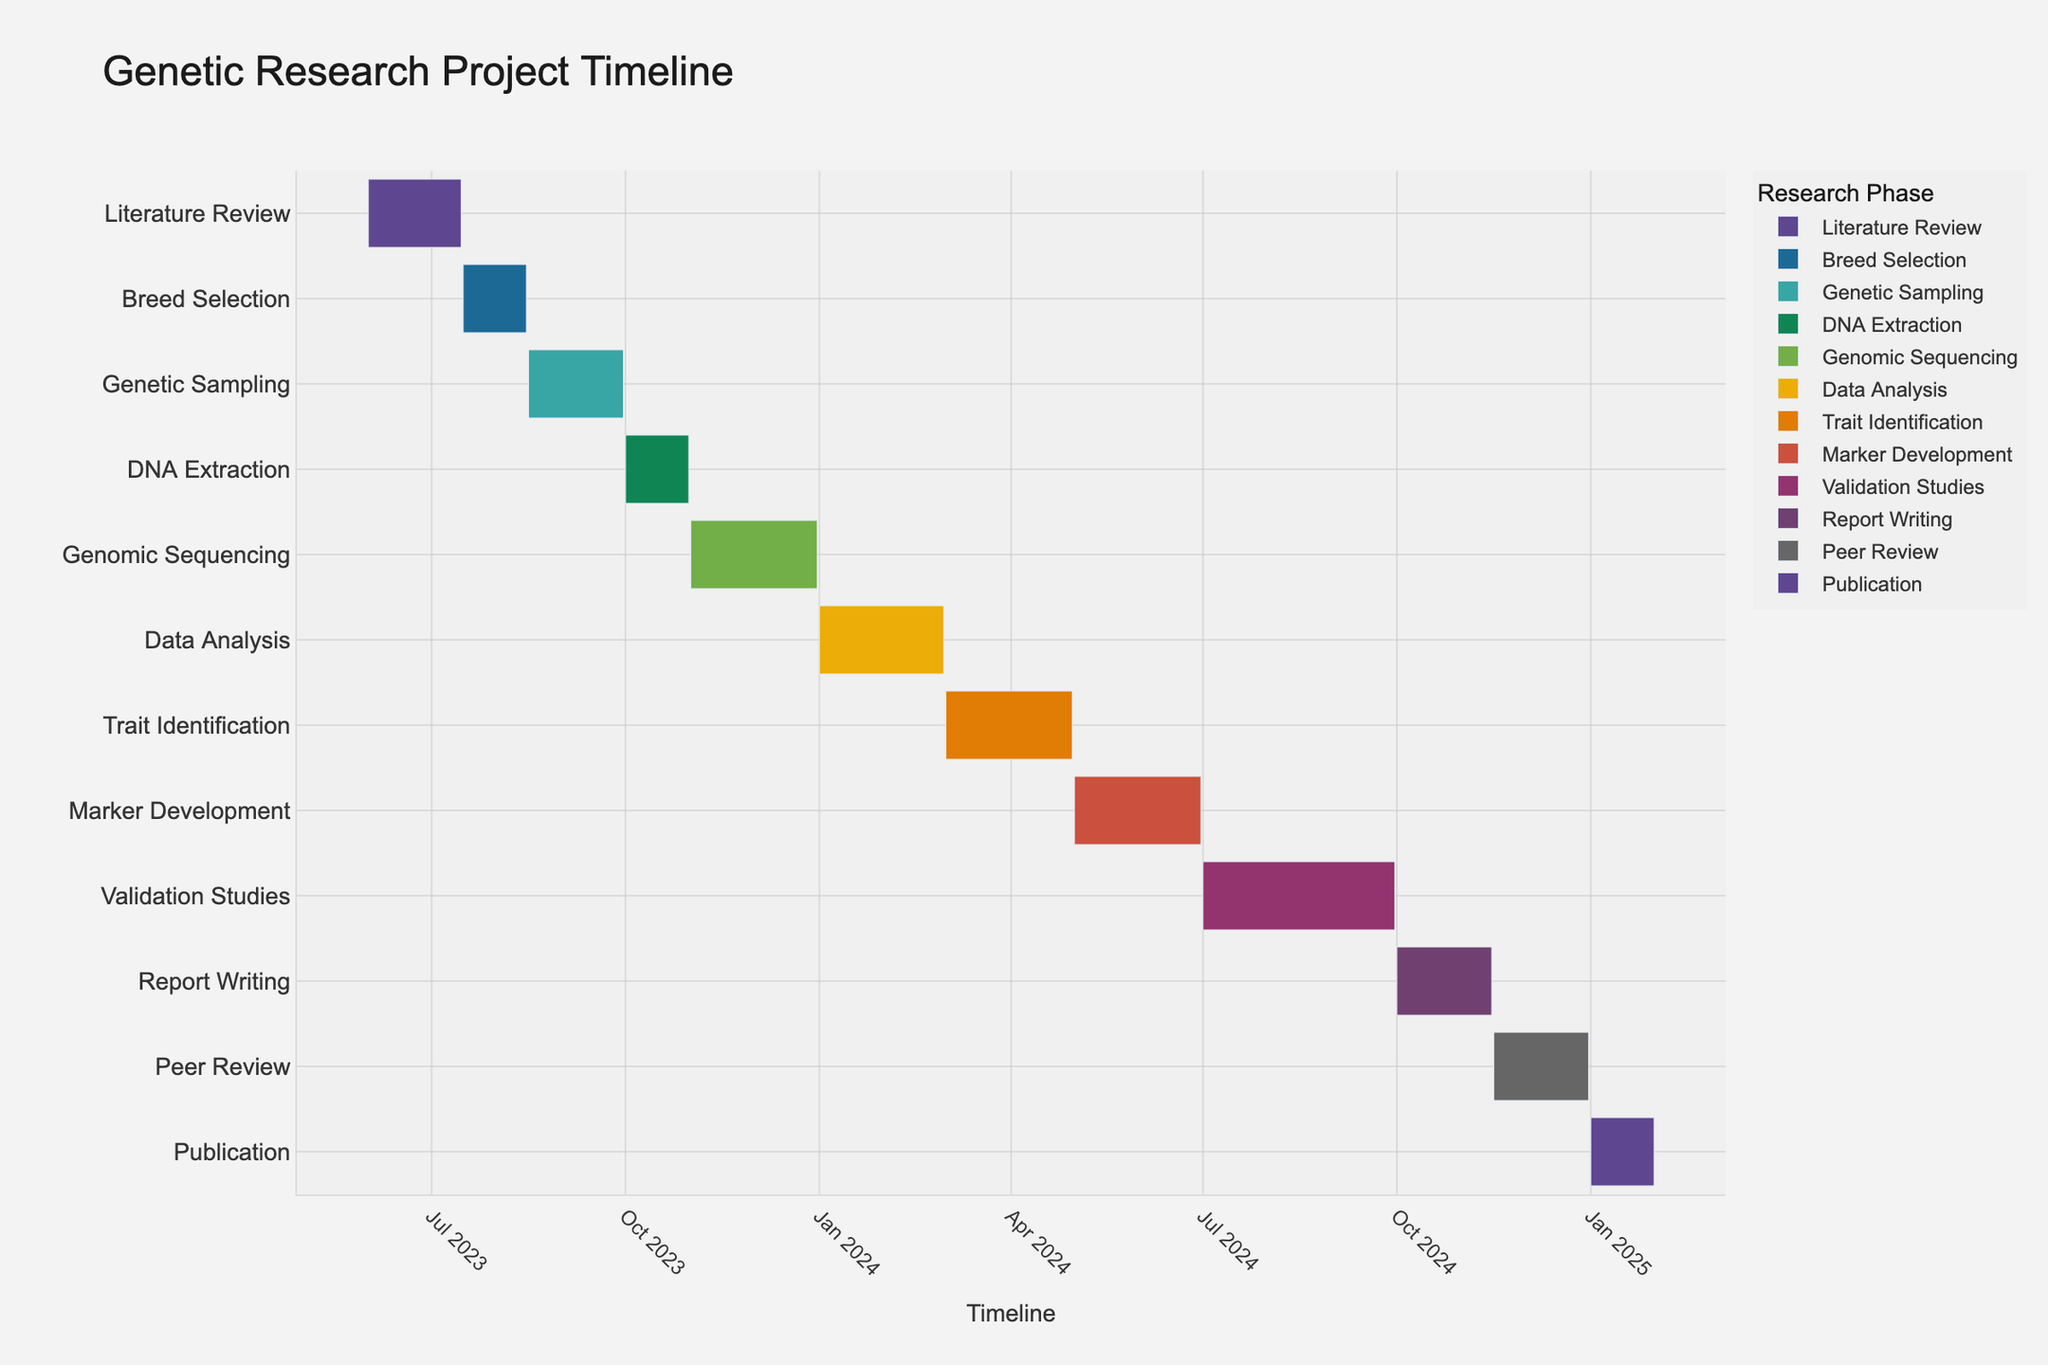What's the title of the Gantt chart? The title of the chart is usually located at the top of the figure. It's bold and larger in size compared to other text elements.
Answer: Genetic Research Project Timeline Which phase has the longest duration? By examining the duration bars, compare their lengths visually. The phase with the longest bar is the one with the longest duration. The "Validation Studies" phase spans from July 1, 2024, to September 30, 2024, which is three months.
Answer: Validation Studies In which month does the "Genetic Sampling" phase start? Find the "Genetic Sampling" phase on the y-axis, then track down the start point on the x-axis. The phase starts on August 16, 2023.
Answer: August 2023 How many research phases are there in total? Count all the distinct tasks listed on the y-axis of the Gantt chart. There are 12 different tasks listed.
Answer: 12 What's the duration of the "Data Analysis" phase in days? Look for the "Data Analysis" phase, then check its start and end dates. "Data Analysis" starts on January 1, 2024, and ends on February 29, 2024. Calculate the number of days between these dates.
Answer: 59 Which two phases have the shortest durations? Visually compare the lengths of all bars and identify the two shortest ones, which are "DNA Extraction" and "Report Writing." Both span roughly a month.
Answer: DNA Extraction and Report Writing During which months does the "Peer Review" phase occur? Find the "Peer Review" phase on the chart and note its start and end points along the x-axis. "Peer Review" starts on November 16, 2024, and ends on December 31, 2024.
Answer: November and December 2024 Which phase follows immediately after "Genomic Sequencing"? Identify the "Genomic Sequencing" phase, and look for the task starting immediately after its end date. "Data Analysis" starts right after "Genomic Sequencing."
Answer: Data Analysis Do any phases overlap between July 2023 and August 2023? Check the timeline within July 2023 to August 2023 and look at the bars to see if any phases overlap. "Literature Review" overlaps with "Breed Selection" in this period.
Answer: Literature Review and Breed Selection How many phases will be ongoing in January 2024? Identify the phases that start before and end after January 2024. The phases "Genomic Sequencing" and "Data Analysis" are ongoing during January 2024.
Answer: Two 